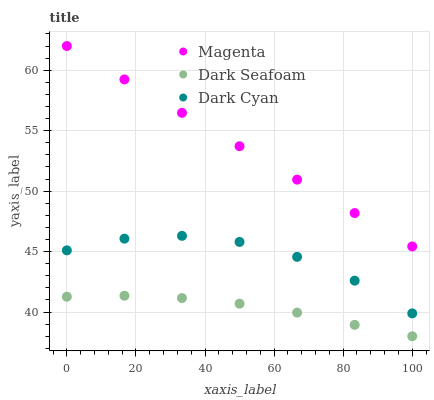Does Dark Seafoam have the minimum area under the curve?
Answer yes or no. Yes. Does Magenta have the maximum area under the curve?
Answer yes or no. Yes. Does Magenta have the minimum area under the curve?
Answer yes or no. No. Does Dark Seafoam have the maximum area under the curve?
Answer yes or no. No. Is Magenta the smoothest?
Answer yes or no. Yes. Is Dark Cyan the roughest?
Answer yes or no. Yes. Is Dark Seafoam the smoothest?
Answer yes or no. No. Is Dark Seafoam the roughest?
Answer yes or no. No. Does Dark Seafoam have the lowest value?
Answer yes or no. Yes. Does Magenta have the lowest value?
Answer yes or no. No. Does Magenta have the highest value?
Answer yes or no. Yes. Does Dark Seafoam have the highest value?
Answer yes or no. No. Is Dark Seafoam less than Magenta?
Answer yes or no. Yes. Is Magenta greater than Dark Seafoam?
Answer yes or no. Yes. Does Dark Seafoam intersect Magenta?
Answer yes or no. No. 